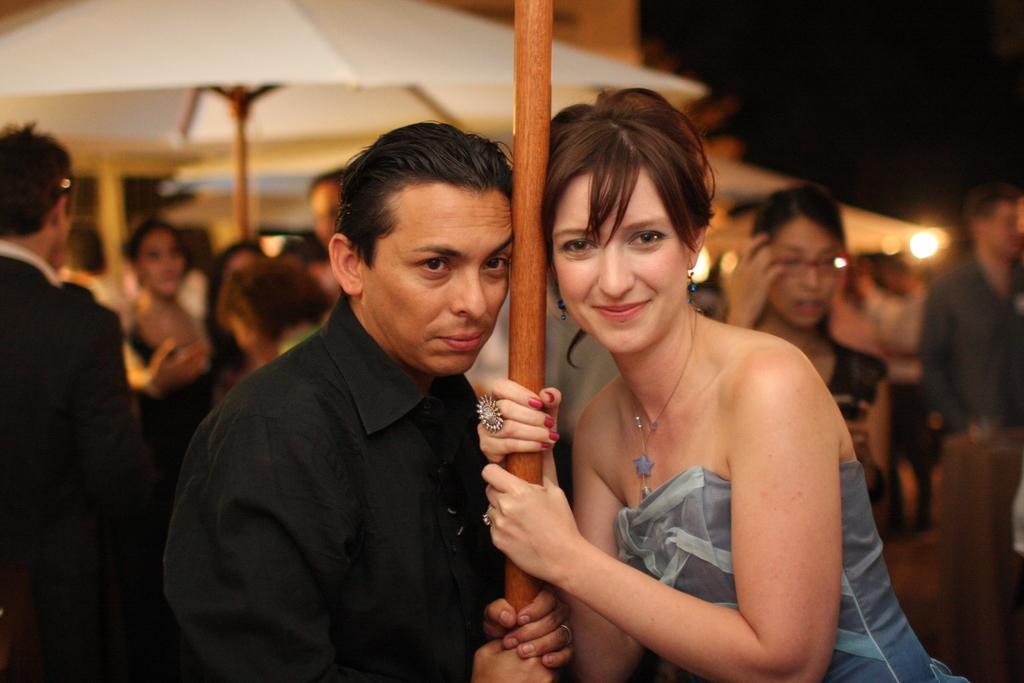Can you describe this image briefly? In this picture I can see a man and a woman standing and holding a wooden stick, and in the background there are group of people standing, there are umbrellas with wooden sticks. 